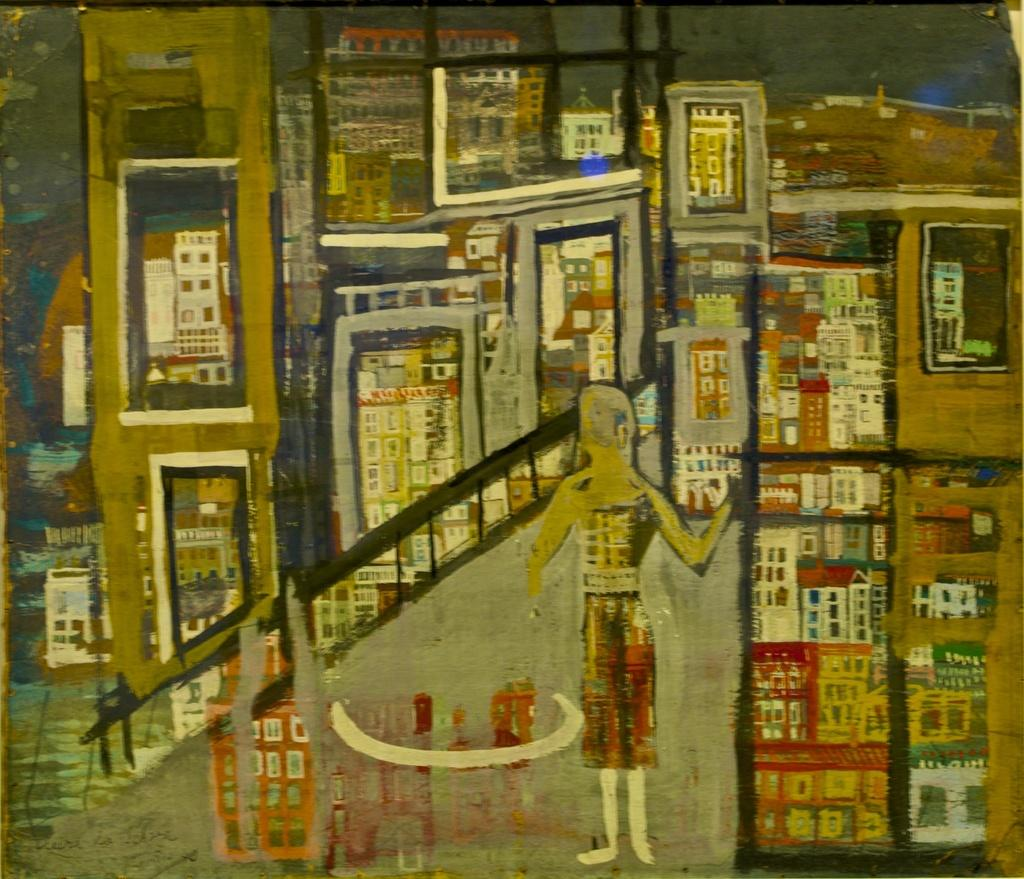What is the main subject of the image? The image contains a painting. What can be seen in the painting? There are many buildings and a bridge in the painting. Are there any people in the painting? Yes, there is a person standing in the painting. How many snakes are slithering across the bridge in the painting? There are no snakes present in the painting; it features buildings, a bridge, and a person. 